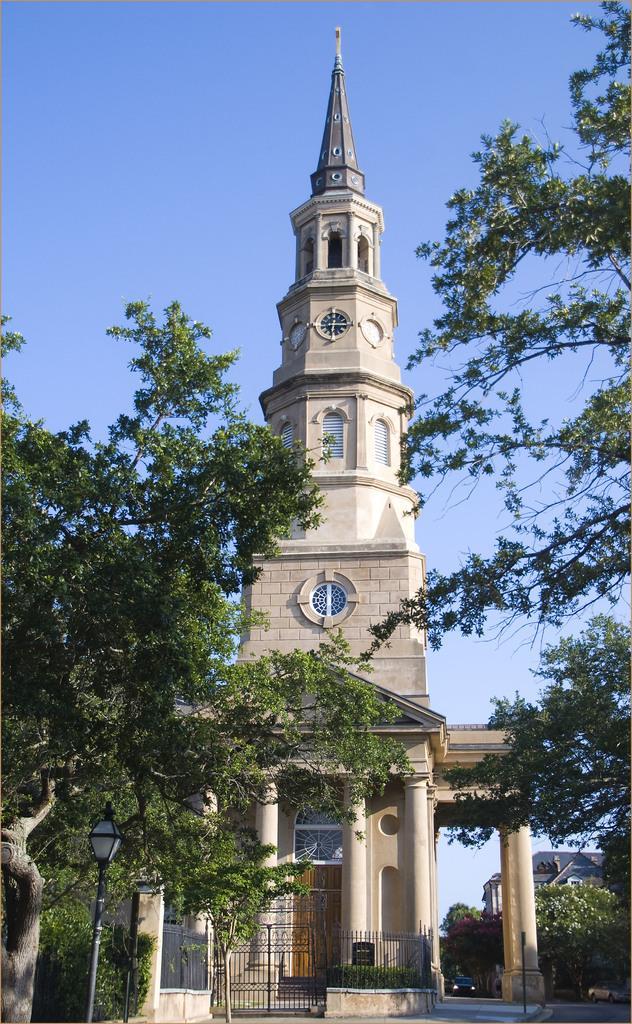In one or two sentences, can you explain what this image depicts? As we can see in the image there are trees, buildings, fence, plants and sky. 